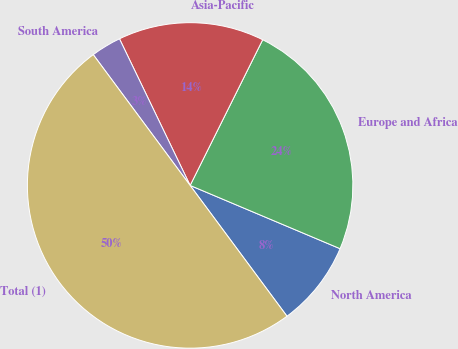<chart> <loc_0><loc_0><loc_500><loc_500><pie_chart><fcel>North America<fcel>Europe and Africa<fcel>Asia-Pacific<fcel>South America<fcel>Total (1)<nl><fcel>8.5%<fcel>24.0%<fcel>14.5%<fcel>3.0%<fcel>50.0%<nl></chart> 